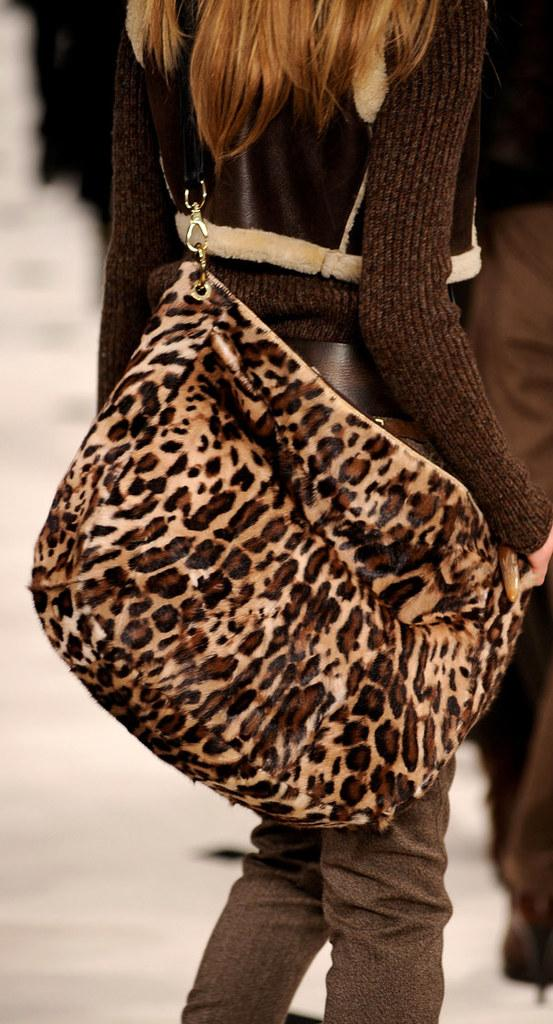Who is present in the image? There is a woman in the image. What is the woman doing in the image? The woman is standing. What type of accessory is the woman wearing? The woman is wearing a leather handbag. What type of police car can be seen in the image? There is no police car present in the image. What type of polish is the woman applying to her nails in the image? There is no indication that the woman is applying any polish to her nails in the image. 